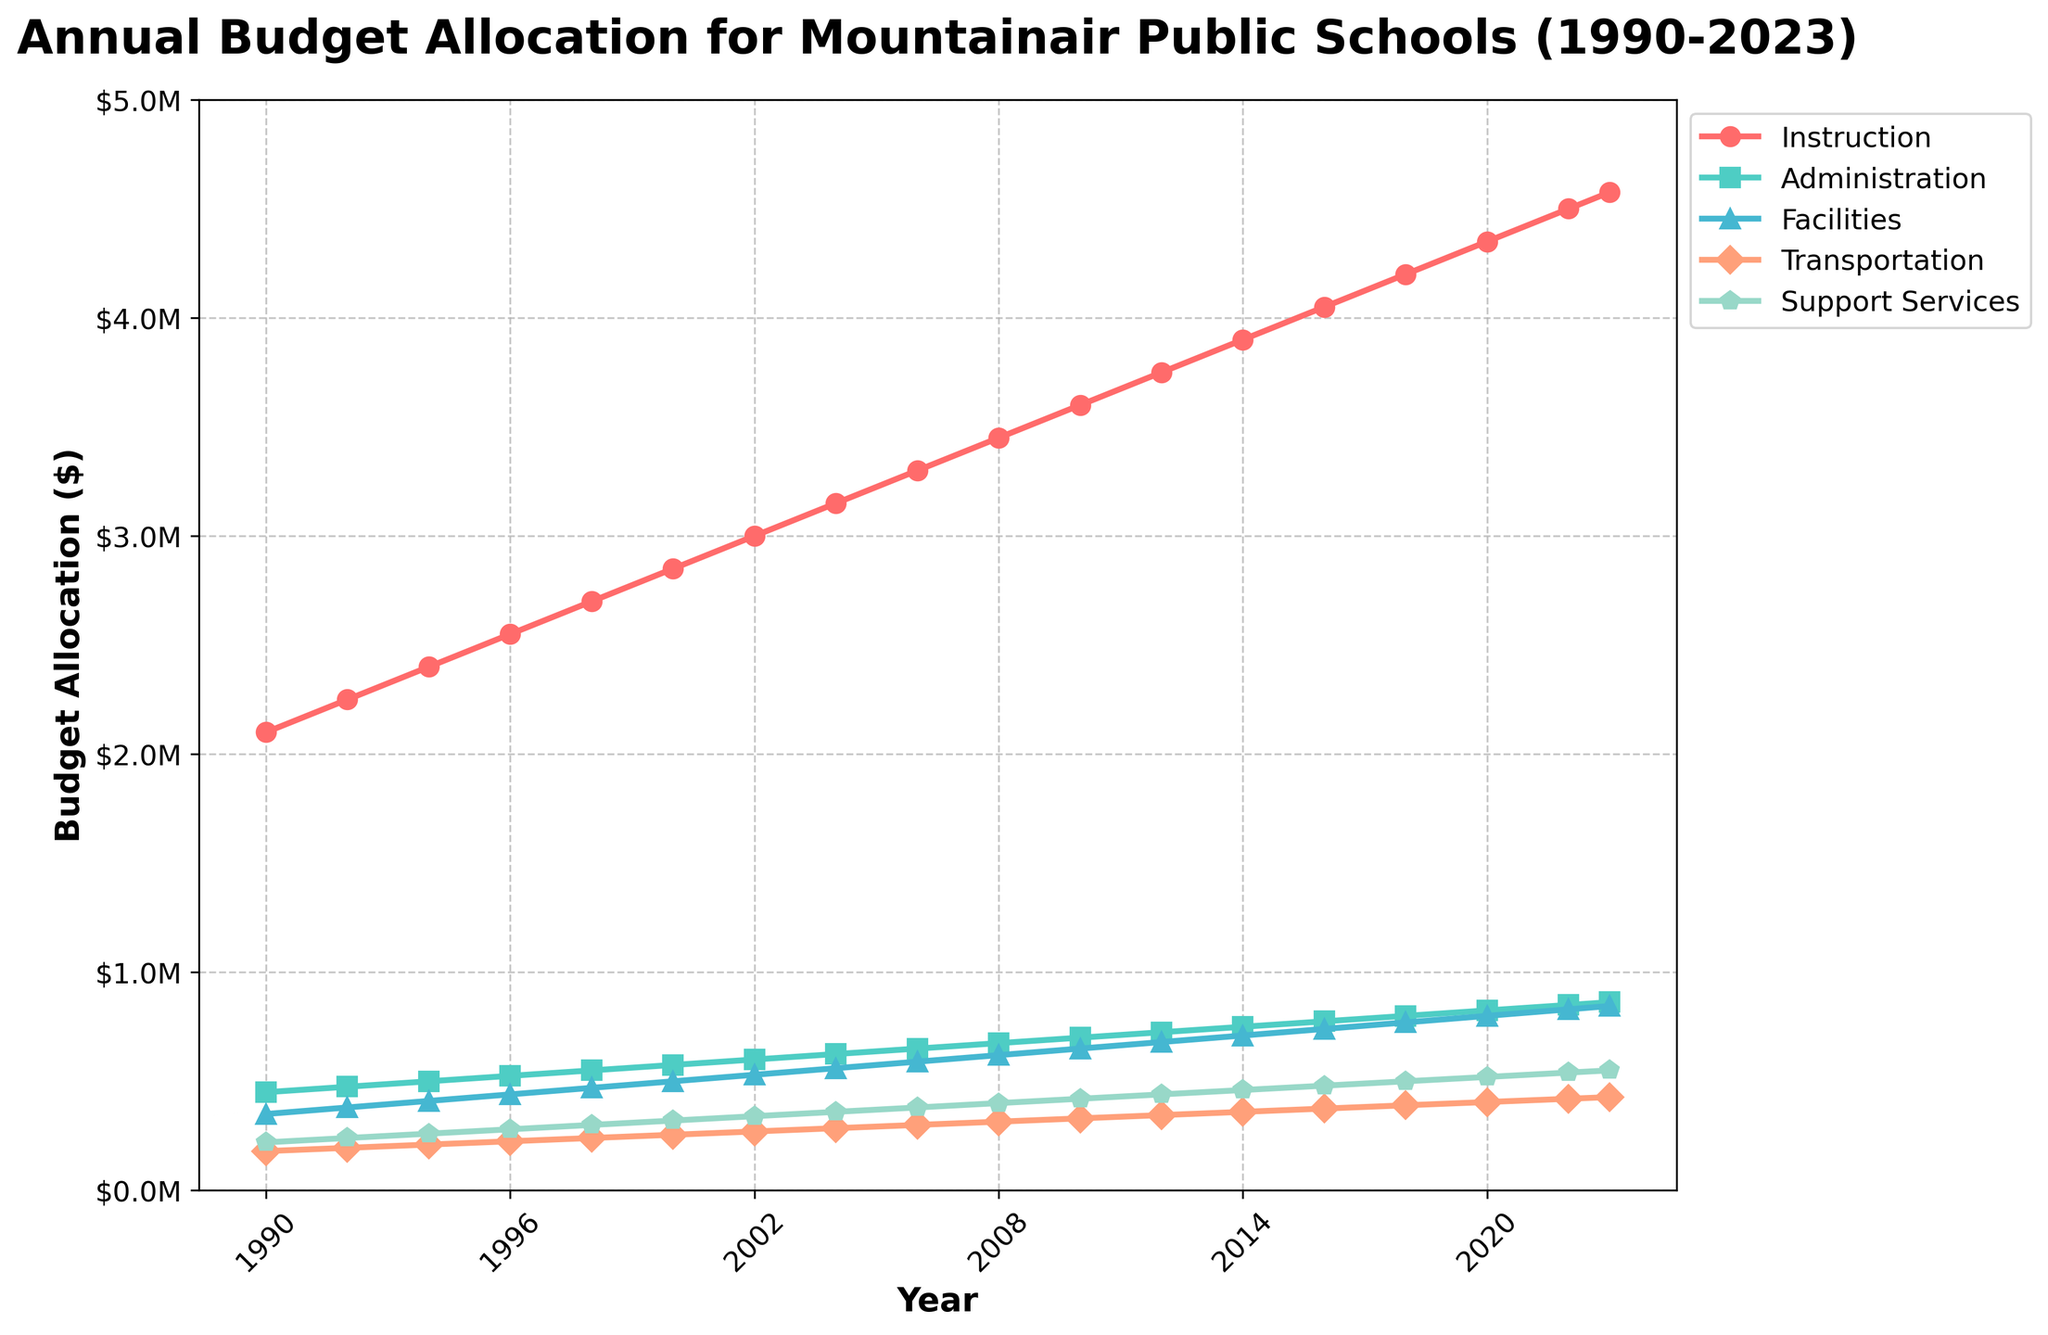What was the budget allocation for Instruction in 1990 and 2023, and how much did it increase? To find the increase, subtract the 1990 value from the 2023 value. The Instruction budget in 1990 was $2,100,000, and in 2023 it was $4,575,000. So, $4,575,000 - $2,100,000 = $2,475,000.
Answer: $2,475,000 Which category had the highest budget allocation in 2023? Compare the 2023 budget allocations for all categories. Instruction has the highest allocation at $4,575,000.
Answer: Instruction By how much did the Support Services allocation increase from 1990 to 2023? To find the increase, subtract the 1990 value from the 2023 value. The Support Services budget in 1990 was $220,000, and in 2023 it was $550,000. So, $550,000 - $220,000 = $330,000.
Answer: $330,000 Did the Administration budget allocation grow faster than the Facilities allocation between 1990 and 2023? Calculate the growth for each category: Administration increased from $450,000 to $862,500, which is $862,500 - $450,000 = $412,500. Facilities increased from $350,000 to $845,000, which is $845,000 - $350,000 = $495,000. Facilities grew faster.
Answer: No What is the average budget allocation for Transportation from 1990 to 2023? Sum all the budget allocations for Transportation from each year and divide by the number of years (2023 - 1990 = 33 years). Total is $180,000 + $195,000 + $210,000 + $225,000 + $240,000 + $255,000 + $270,000 + $285,000 + $300,000 + $315,000 + $330,000 + $345,000 + $360,000 + $375,000 + $390,000 + $405,000 + $420,000 + $427,500 = $5,698,500. Average is $5,698,500 / 18 = $316,583.33.
Answer: $316,583.33 Which year saw the largest increase in the Administration budget? Calculate the year-over-year increase for Administration: 1992: $25,000, 1994: $25,000, 1996: $25,000, 1998: $25,000, 2000: $25,000, 2002: $25,000, 2004: $25,000, 2006: $25,000, 2008: $25,000, 2010: $25,000, 2012: $25,000, 2014: $25,000, 2016: $25,000, 2018: $25,000, 2020: $25,000, 2022: $25,000, 2023: $12,500. The largest increase is consistently $25,000.
Answer: 1992 (and other years) How does the Transportation budget in 1990 compare to the Support Services budget in 1990? Compare the budget values. Transportation in 1990 was $180,000, while Support Services was $220,000.
Answer: Support Services was higher What was the total budget allocation for Facilities between 1990 and 2023? Sum all the budget allocations for Facilities from each year. Total is $350,000 + $380,000 + $410,000 + $440,000 + $470,000 + $500,000 + $530,000 + $560,000 + $590,000 + $620,000 + $650,000 + $680,000 + $710,000 + $740,000 + $770,000 + $800,000 + $830,000 + $845,000 = $11,975,000.
Answer: $11,975,000 